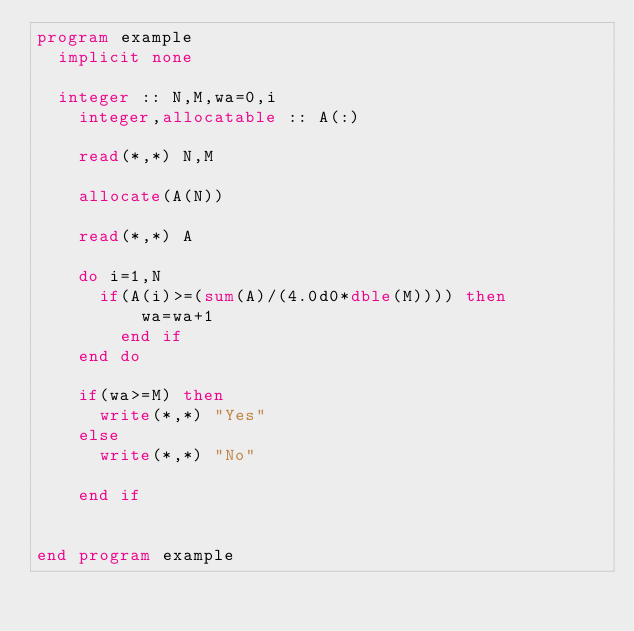Convert code to text. <code><loc_0><loc_0><loc_500><loc_500><_FORTRAN_>program example
	implicit none

	integer :: N,M,wa=0,i
    integer,allocatable :: A(:)
    
    read(*,*) N,M
    
    allocate(A(N))
    
    read(*,*) A

    do i=1,N
    	if(A(i)>=(sum(A)/(4.0d0*dble(M)))) then
        	wa=wa+1
        end if
    end do
    
    if(wa>=M) then
    	write(*,*) "Yes"
    else
    	write(*,*) "No"
        
    end if
    

end program example
</code> 